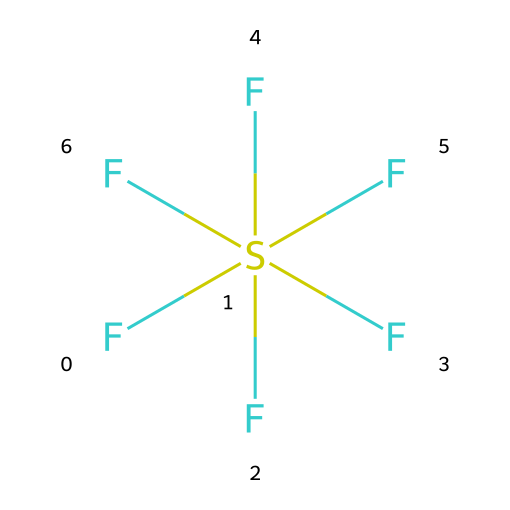What is the chemical name for this compound? The chemical structure corresponds to sulfur hexafluoride, indicated by the sulfur atom bonded to six fluorine atoms.
Answer: sulfur hexafluoride How many fluorine atoms are present in the molecule? By examining the structure, there are six fluorine atoms bonded to one sulfur atom.
Answer: 6 What is the hybridization of the central sulfur atom in sulfur hexafluoride? The sulfur atom forms six equivalent bonds with fluorine, indicating it has an octahedral geometry and sp^3d^2 hybridization.
Answer: sp^3d^2 Is this molecule polar or nonpolar? The symmetry of the six equivalent fluorine atoms around the sulfur leads to a nonpolar character since the dipoles cancel each other out.
Answer: nonpolar What is the primary characteristic of hypervalent compounds exhibited by this structure? Hypervalent compounds can have a central atom that expands its valency beyond the octet rule, which is shown here with sulfur using more than 8 electrons in bonding.
Answer: expanded valency What type of bonding is predominantly present in sulfur hexafluoride? The sulfur-fluorine bonds are primarily covalent in nature, as they involve sharing of electron pairs between sulfur and fluorine.
Answer: covalent How does the molecular arrangement contribute to the insulation properties of sulfur hexafluoride? The molecular geometry and nonpolar nature reduce reactivity and enhance electrical resistance, making it an effective insulator for space electronics.
Answer: electrical resistance 